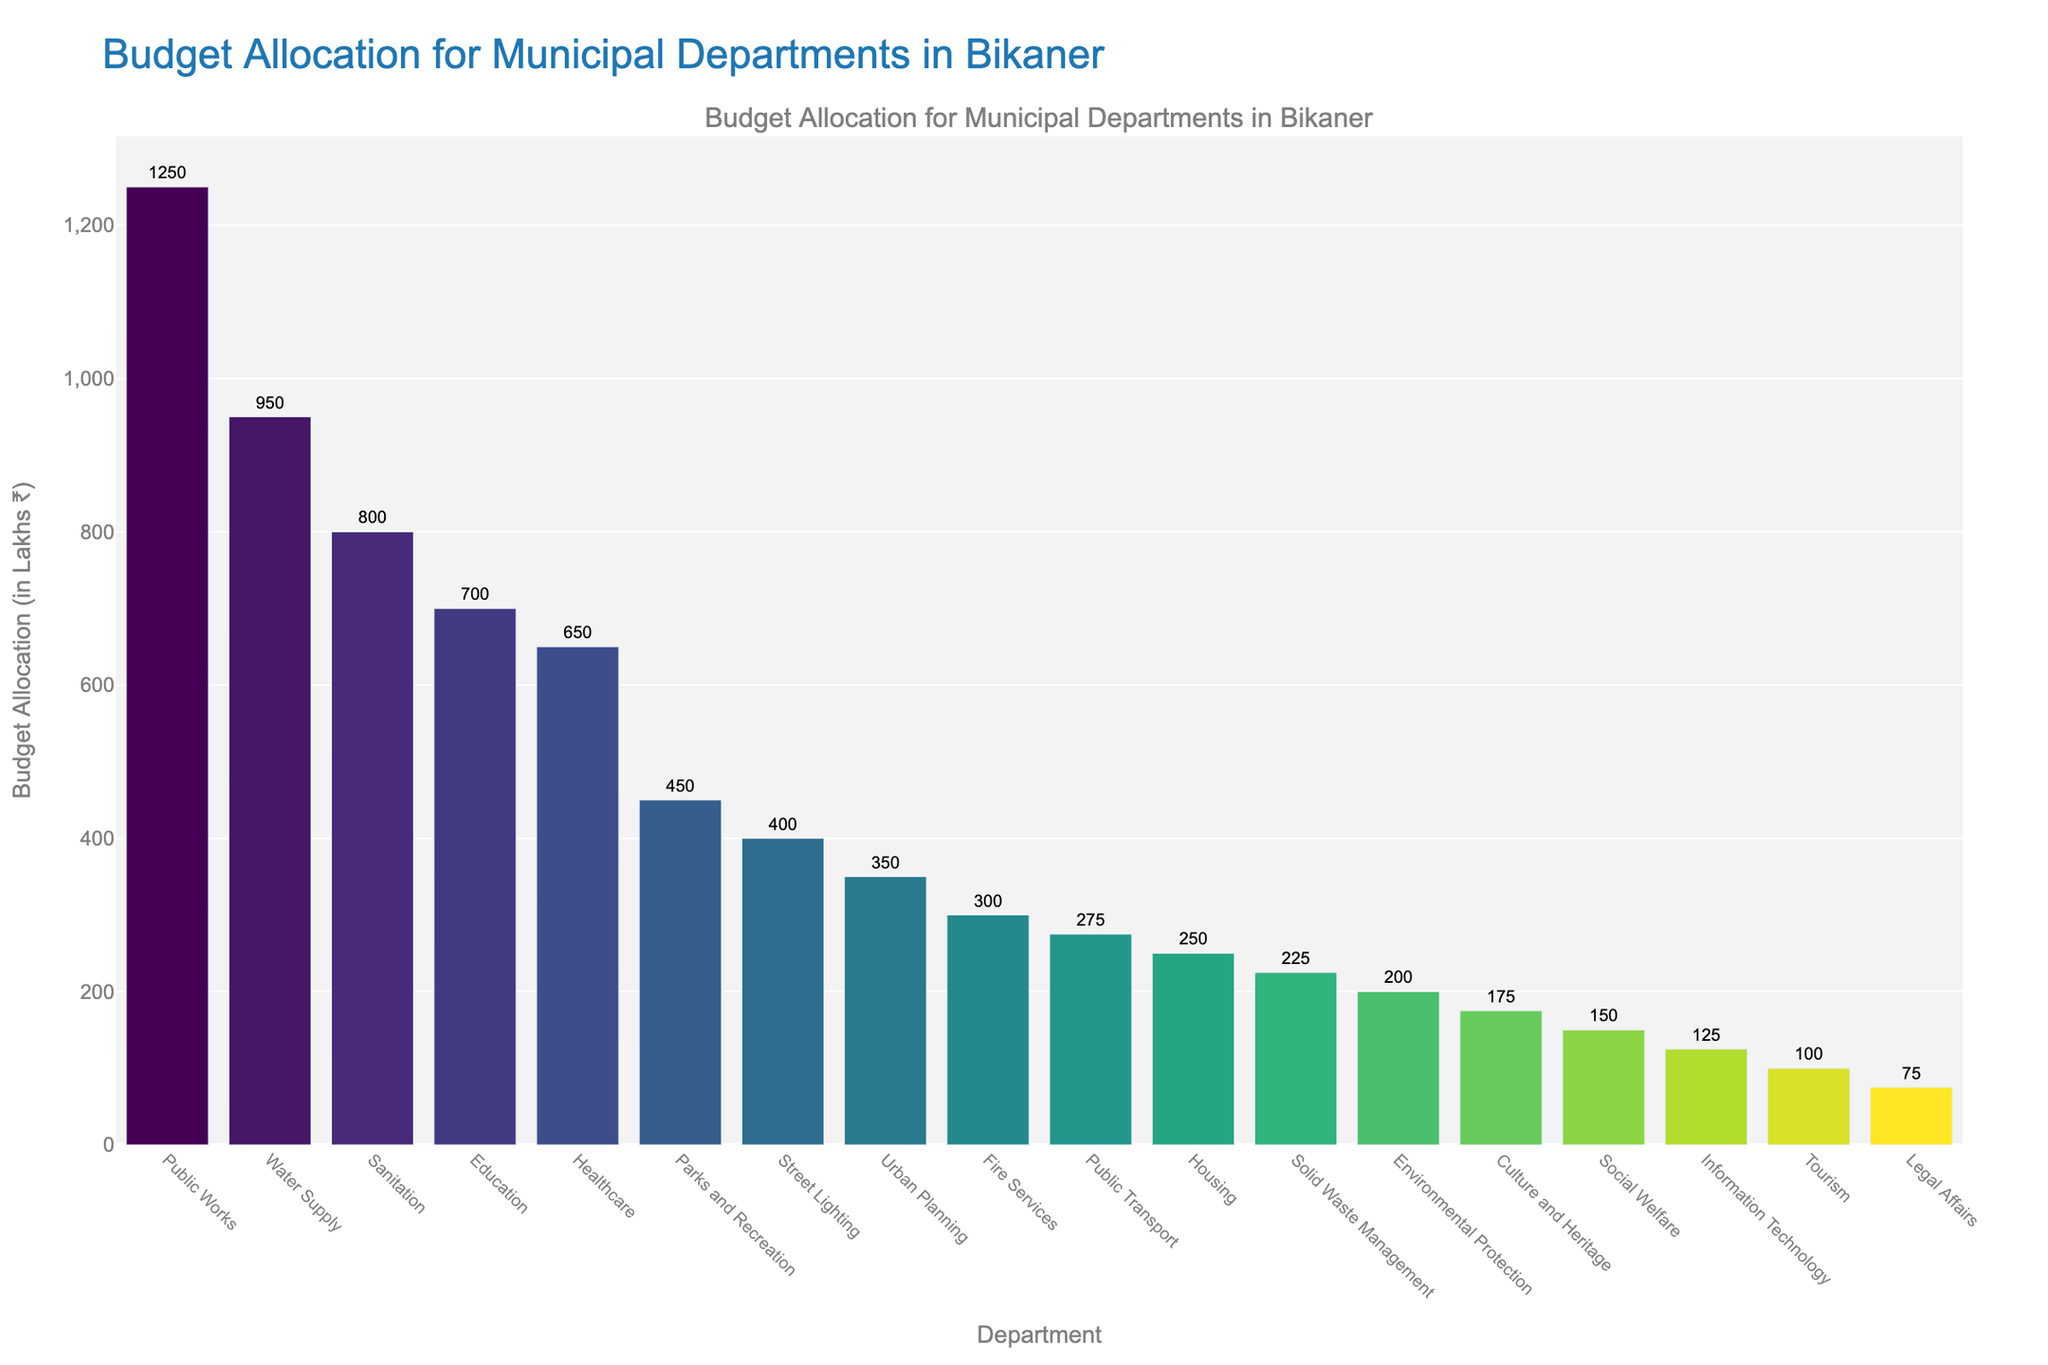Which department has the highest budget allocation? The bar chart shows the budget allocation in descending order, and the highest bar corresponds to the Public Works department.
Answer: Public Works Which three departments have the lowest budget allocations? By looking at the shortest bars in the chart, the lowest budget allocations are for Legal Affairs, Tourism, and Information Technology.
Answer: Legal Affairs, Tourism, Information Technology What is the total budget allocation for the top 3 departments? The top three departments are Public Works, Water Supply, and Sanitation with budget allocations of ₹1250 Lakhs, ₹950 Lakhs, and ₹800 Lakhs respectively. The total is 1250 + 950 + 800 = 3000 Lakhs.
Answer: 3000 Lakhs Which department has a higher budget allocation, Healthcare or Education, and by how much? Comparing the heights, the Education department has ₹700 Lakhs, and Healthcare has ₹650 Lakhs. The difference is 700 - 650 = ₹50 Lakhs.
Answer: Education by ₹50 Lakhs How many departments have a budget allocation of 500 Lakhs or more? From the figure, identify the bars that reach 500 Lakhs or higher. These departments are: Public Works, Water Supply, Sanitation, Education, and Healthcare, totaling 5 departments.
Answer: 5 departments What is the average budget allocation across all departments? Sum all the budget allocations and divide by the number of departments. (1250 + 950 + 800 + 700 + 650 + 450 + 400 + 350 + 300 + 275 + 250 + 225 + 200 + 175 + 150 + 125 + 100 + 75) / 18 = 7350 / 18 = ₹408.33 Lakhs (approx).
Answer: ₹408.33 Lakhs Which has a higher budget allocation: Solid Waste Management or Street Lighting? The bar for Solid Waste Management is below the bar for Street Lighting. Solid Waste Management has ₹225 Lakhs compared to Street Lighting’s ₹400 Lakhs.
Answer: Street Lighting What is the range of the budget allocations in the chart? The highest budget allocation is ₹1250 Lakhs (Public Works), and the lowest is ₹75 Lakhs (Legal Affairs). The range is 1250 - 75 = ₹1175 Lakhs.
Answer: ₹1175 Lakhs How much more is the budget for Water Supply compared to Urban Planning? The budget for Water Supply is ₹950 Lakhs, while Urban Planning has ₹350 Lakhs. The difference is 950 - 350 = ₹600 Lakhs.
Answer: ₹600 Lakhs 